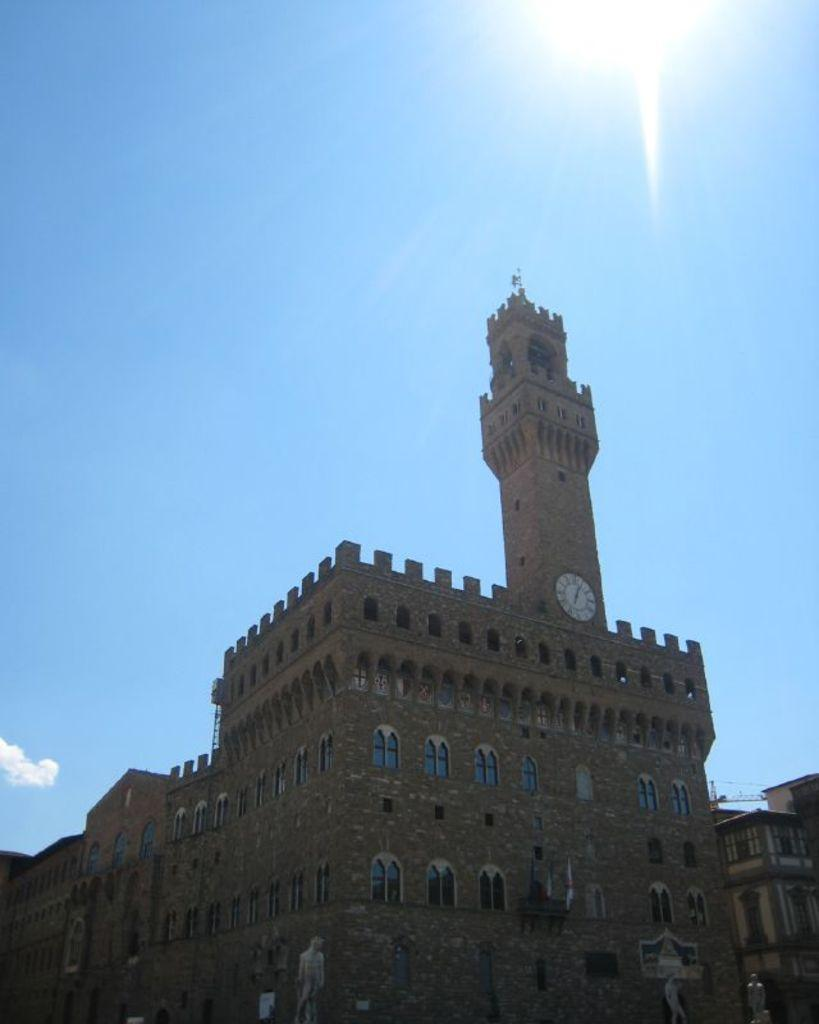What type of structure is present in the picture? There is a building in the picture. Can you describe any specific features of the building? There is a tower with a clock in the picture. What is the condition of the sky in the image? The sky is clear in the picture. What type of jar can be seen on top of the tower in the image? There is no jar present on top of the tower in the image. Can you describe the feathers that are falling from the sky in the image? There are no feathers falling from the sky in the image; the sky is clear. 